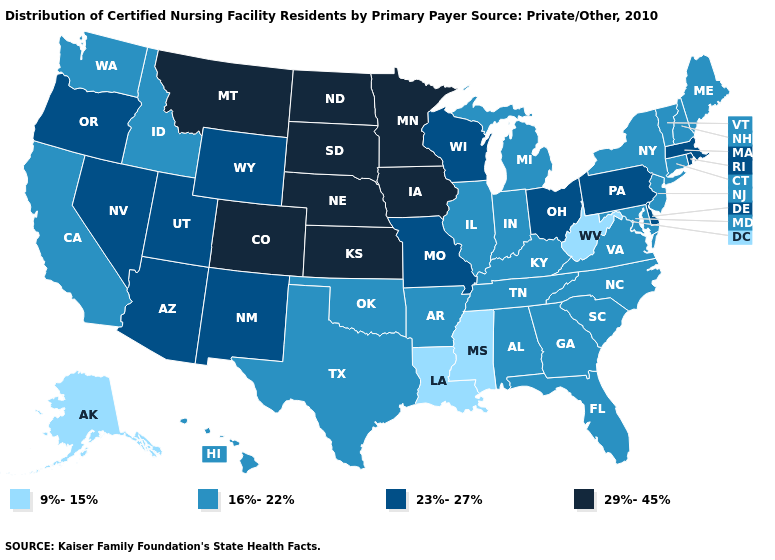Does Connecticut have the lowest value in the Northeast?
Give a very brief answer. Yes. What is the highest value in the USA?
Short answer required. 29%-45%. Does Hawaii have a lower value than Alabama?
Quick response, please. No. What is the highest value in the South ?
Write a very short answer. 23%-27%. Name the states that have a value in the range 23%-27%?
Quick response, please. Arizona, Delaware, Massachusetts, Missouri, Nevada, New Mexico, Ohio, Oregon, Pennsylvania, Rhode Island, Utah, Wisconsin, Wyoming. Which states have the highest value in the USA?
Quick response, please. Colorado, Iowa, Kansas, Minnesota, Montana, Nebraska, North Dakota, South Dakota. Name the states that have a value in the range 16%-22%?
Quick response, please. Alabama, Arkansas, California, Connecticut, Florida, Georgia, Hawaii, Idaho, Illinois, Indiana, Kentucky, Maine, Maryland, Michigan, New Hampshire, New Jersey, New York, North Carolina, Oklahoma, South Carolina, Tennessee, Texas, Vermont, Virginia, Washington. Name the states that have a value in the range 23%-27%?
Be succinct. Arizona, Delaware, Massachusetts, Missouri, Nevada, New Mexico, Ohio, Oregon, Pennsylvania, Rhode Island, Utah, Wisconsin, Wyoming. Name the states that have a value in the range 9%-15%?
Keep it brief. Alaska, Louisiana, Mississippi, West Virginia. What is the value of Kansas?
Concise answer only. 29%-45%. What is the highest value in states that border Utah?
Short answer required. 29%-45%. Name the states that have a value in the range 9%-15%?
Answer briefly. Alaska, Louisiana, Mississippi, West Virginia. Does the map have missing data?
Short answer required. No. Does Virginia have a higher value than Alabama?
Concise answer only. No. What is the lowest value in the MidWest?
Keep it brief. 16%-22%. 